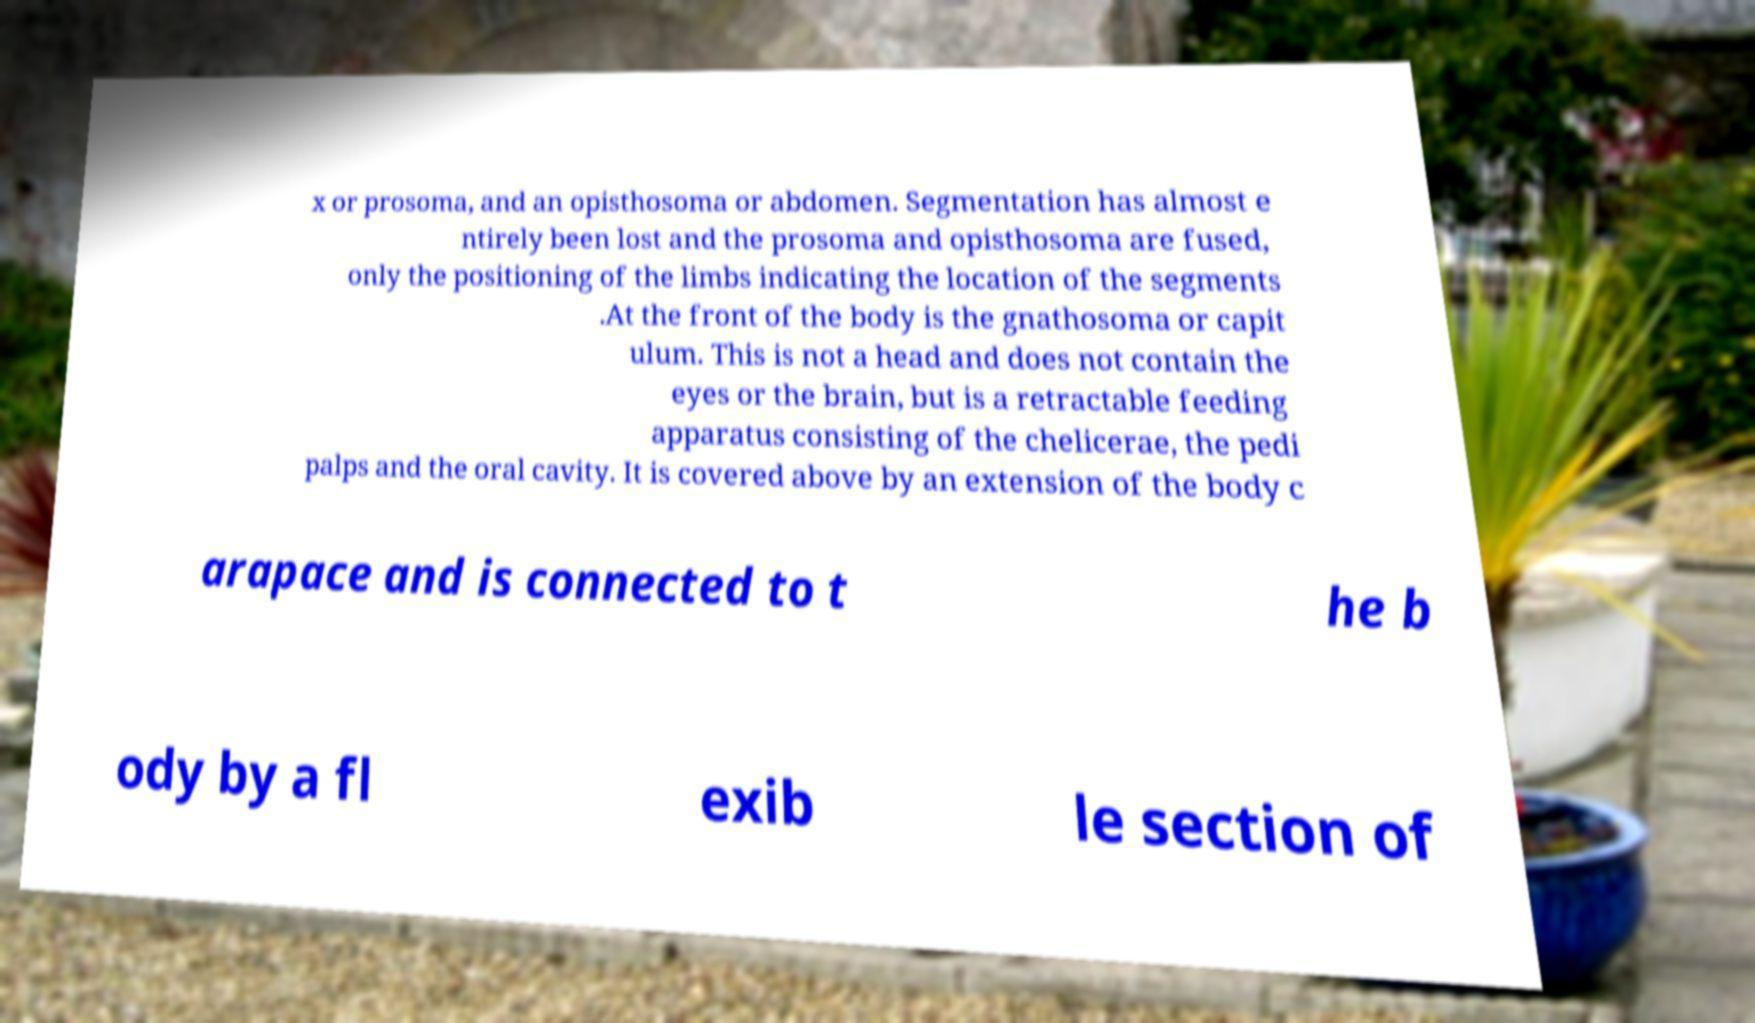Please identify and transcribe the text found in this image. x or prosoma, and an opisthosoma or abdomen. Segmentation has almost e ntirely been lost and the prosoma and opisthosoma are fused, only the positioning of the limbs indicating the location of the segments .At the front of the body is the gnathosoma or capit ulum. This is not a head and does not contain the eyes or the brain, but is a retractable feeding apparatus consisting of the chelicerae, the pedi palps and the oral cavity. It is covered above by an extension of the body c arapace and is connected to t he b ody by a fl exib le section of 